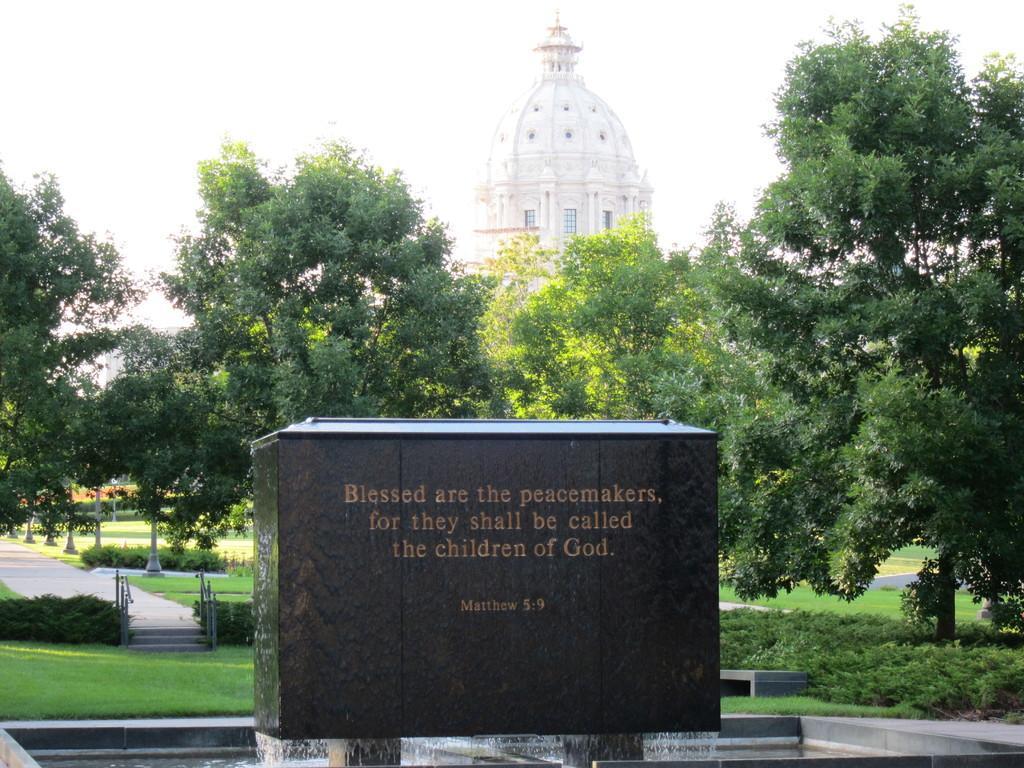How would you summarize this image in a sentence or two? In this image in the center there is one wall, on the wall there is text and at the bottom it looks like a fountain. And in the background there is building, walkway and stairs. 